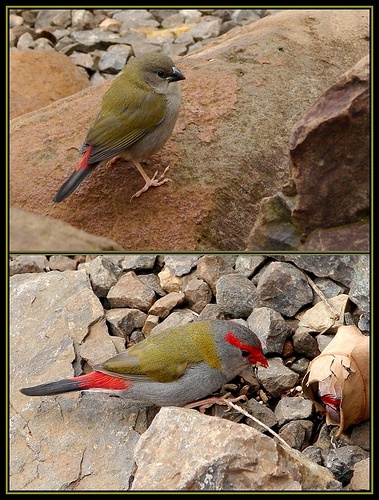Describe the objects in this image and their specific colors. I can see bird in black, gray, tan, olive, and darkgray tones and bird in black, olive, maroon, and gray tones in this image. 